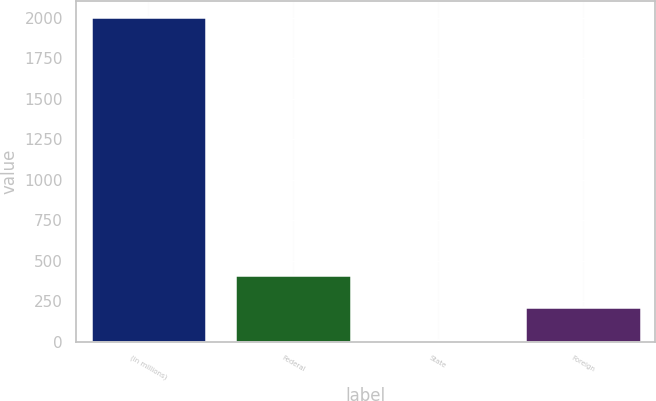Convert chart to OTSL. <chart><loc_0><loc_0><loc_500><loc_500><bar_chart><fcel>(in millions)<fcel>Federal<fcel>State<fcel>Foreign<nl><fcel>2004<fcel>411.12<fcel>12.9<fcel>212.01<nl></chart> 